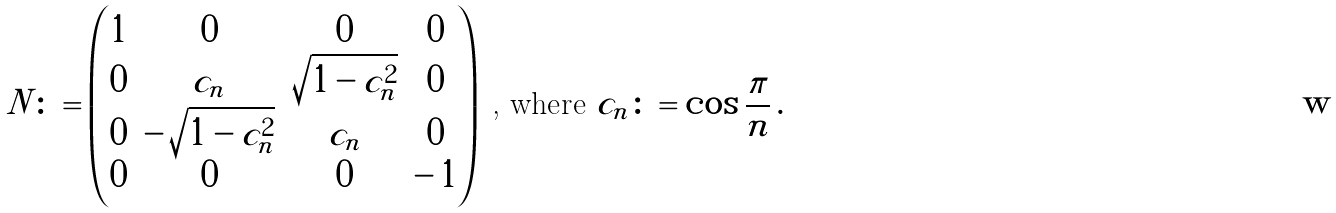<formula> <loc_0><loc_0><loc_500><loc_500>N \colon = \begin{pmatrix} 1 & 0 & 0 & 0 \\ 0 & c _ { n } & \sqrt { 1 - c _ { n } ^ { 2 } } & 0 \\ 0 & - \, \sqrt { 1 - c _ { n } ^ { 2 } } & c _ { n } & 0 \\ 0 & 0 & 0 & - \, 1 \end{pmatrix} \text { , where } c _ { n } \colon = \cos \frac { \pi } { n } \, .</formula> 